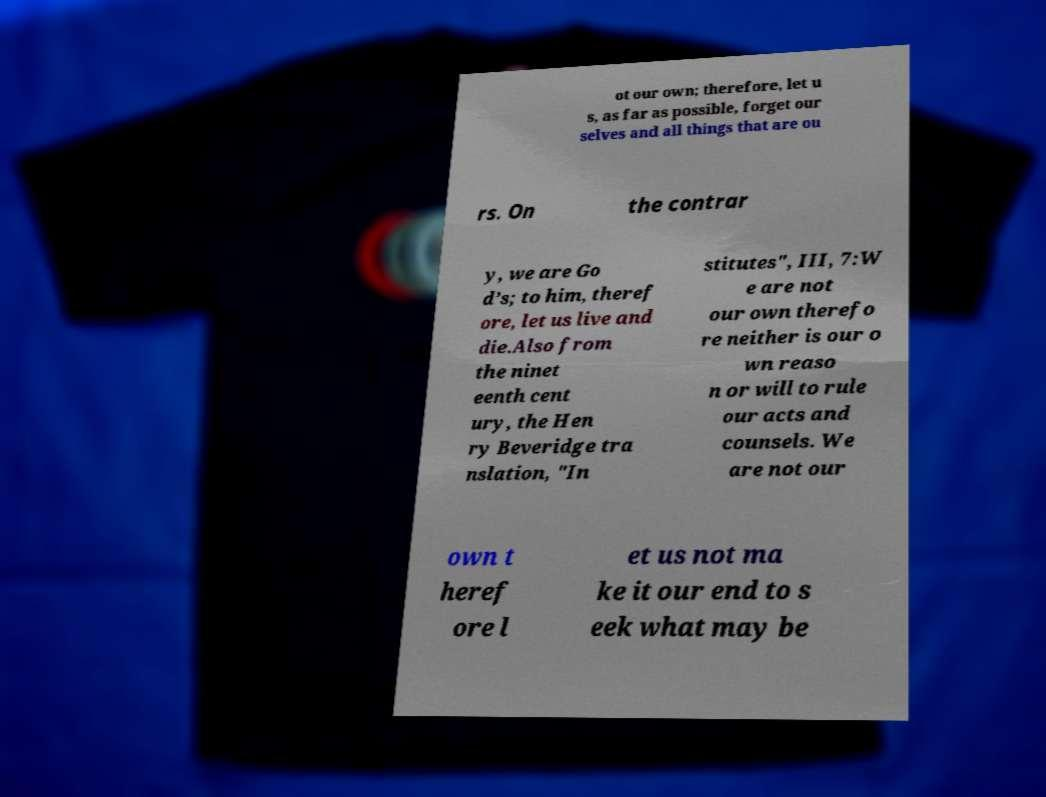Can you accurately transcribe the text from the provided image for me? ot our own; therefore, let u s, as far as possible, forget our selves and all things that are ou rs. On the contrar y, we are Go d’s; to him, theref ore, let us live and die.Also from the ninet eenth cent ury, the Hen ry Beveridge tra nslation, "In stitutes", III, 7:W e are not our own therefo re neither is our o wn reaso n or will to rule our acts and counsels. We are not our own t heref ore l et us not ma ke it our end to s eek what may be 